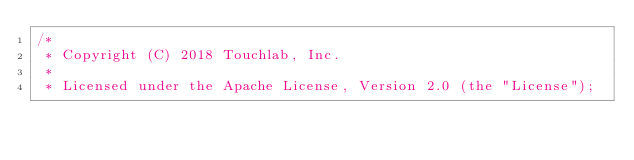<code> <loc_0><loc_0><loc_500><loc_500><_Kotlin_>/*
 * Copyright (C) 2018 Touchlab, Inc.
 *
 * Licensed under the Apache License, Version 2.0 (the "License");</code> 